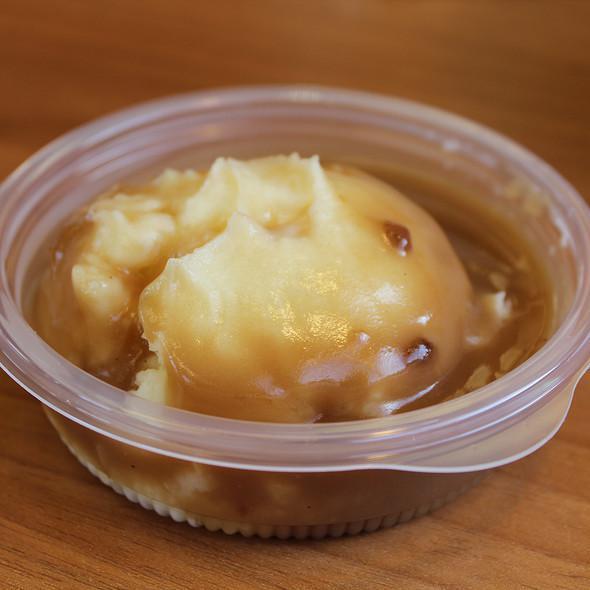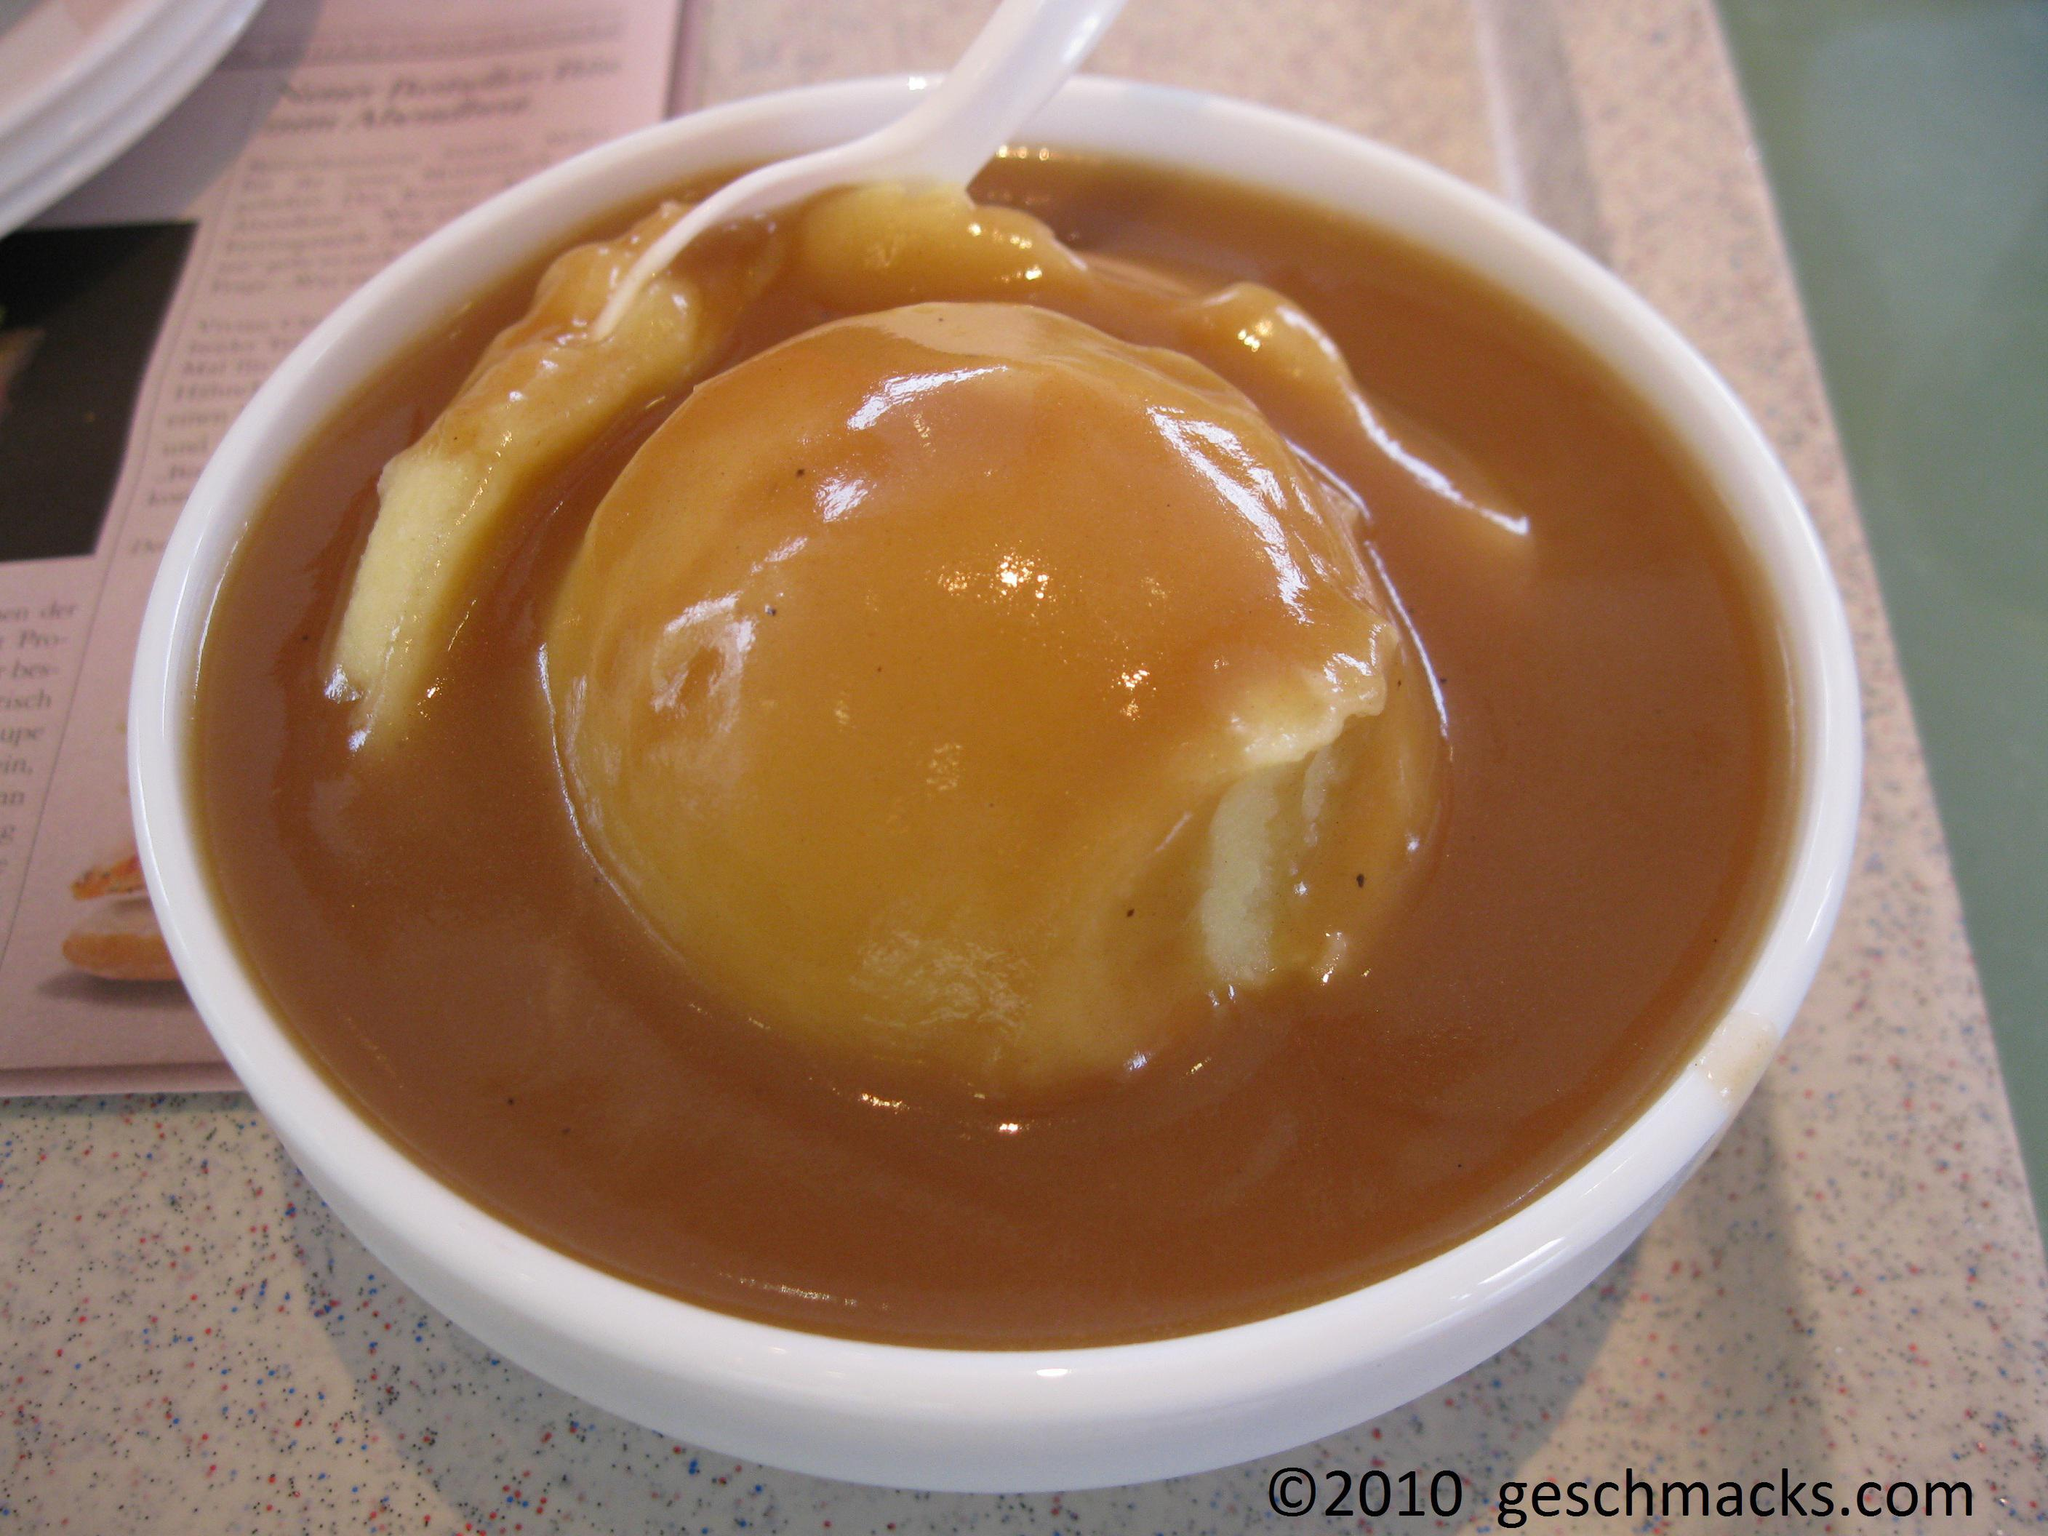The first image is the image on the left, the second image is the image on the right. For the images shown, is this caption "The mashed potatoes on the right picture has a spoon in its container." true? Answer yes or no. Yes. 